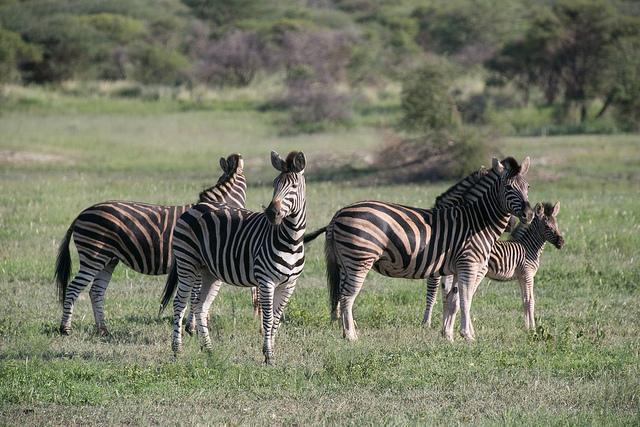How many zebras are present?
Give a very brief answer. 4. How many zebras are resting?
Give a very brief answer. 0. How many zebras are there?
Give a very brief answer. 4. How many dogs in the car?
Give a very brief answer. 0. 